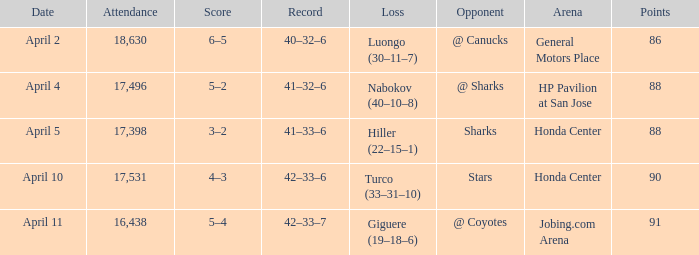On what date was the Record 41–32–6? April 4. 